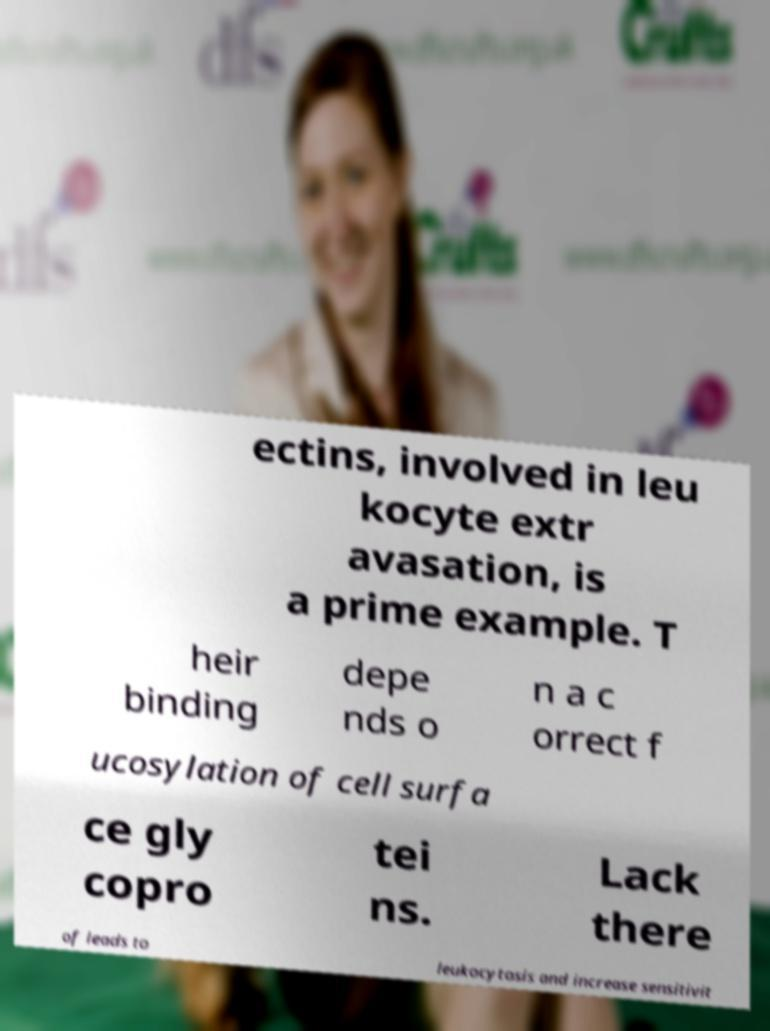Please read and relay the text visible in this image. What does it say? ectins, involved in leu kocyte extr avasation, is a prime example. T heir binding depe nds o n a c orrect f ucosylation of cell surfa ce gly copro tei ns. Lack there of leads to leukocytosis and increase sensitivit 